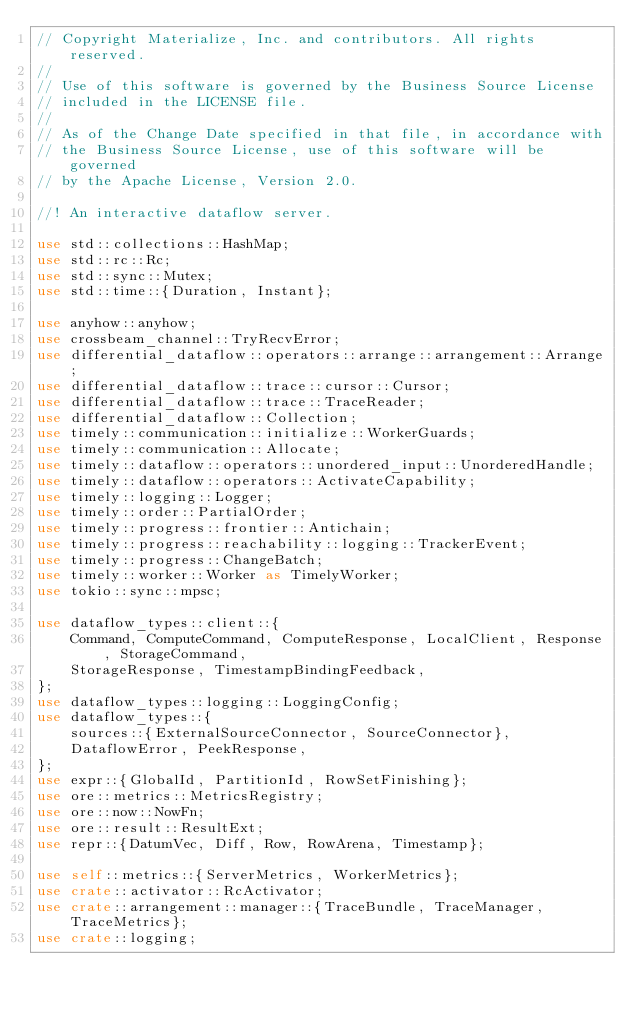<code> <loc_0><loc_0><loc_500><loc_500><_Rust_>// Copyright Materialize, Inc. and contributors. All rights reserved.
//
// Use of this software is governed by the Business Source License
// included in the LICENSE file.
//
// As of the Change Date specified in that file, in accordance with
// the Business Source License, use of this software will be governed
// by the Apache License, Version 2.0.

//! An interactive dataflow server.

use std::collections::HashMap;
use std::rc::Rc;
use std::sync::Mutex;
use std::time::{Duration, Instant};

use anyhow::anyhow;
use crossbeam_channel::TryRecvError;
use differential_dataflow::operators::arrange::arrangement::Arrange;
use differential_dataflow::trace::cursor::Cursor;
use differential_dataflow::trace::TraceReader;
use differential_dataflow::Collection;
use timely::communication::initialize::WorkerGuards;
use timely::communication::Allocate;
use timely::dataflow::operators::unordered_input::UnorderedHandle;
use timely::dataflow::operators::ActivateCapability;
use timely::logging::Logger;
use timely::order::PartialOrder;
use timely::progress::frontier::Antichain;
use timely::progress::reachability::logging::TrackerEvent;
use timely::progress::ChangeBatch;
use timely::worker::Worker as TimelyWorker;
use tokio::sync::mpsc;

use dataflow_types::client::{
    Command, ComputeCommand, ComputeResponse, LocalClient, Response, StorageCommand,
    StorageResponse, TimestampBindingFeedback,
};
use dataflow_types::logging::LoggingConfig;
use dataflow_types::{
    sources::{ExternalSourceConnector, SourceConnector},
    DataflowError, PeekResponse,
};
use expr::{GlobalId, PartitionId, RowSetFinishing};
use ore::metrics::MetricsRegistry;
use ore::now::NowFn;
use ore::result::ResultExt;
use repr::{DatumVec, Diff, Row, RowArena, Timestamp};

use self::metrics::{ServerMetrics, WorkerMetrics};
use crate::activator::RcActivator;
use crate::arrangement::manager::{TraceBundle, TraceManager, TraceMetrics};
use crate::logging;</code> 